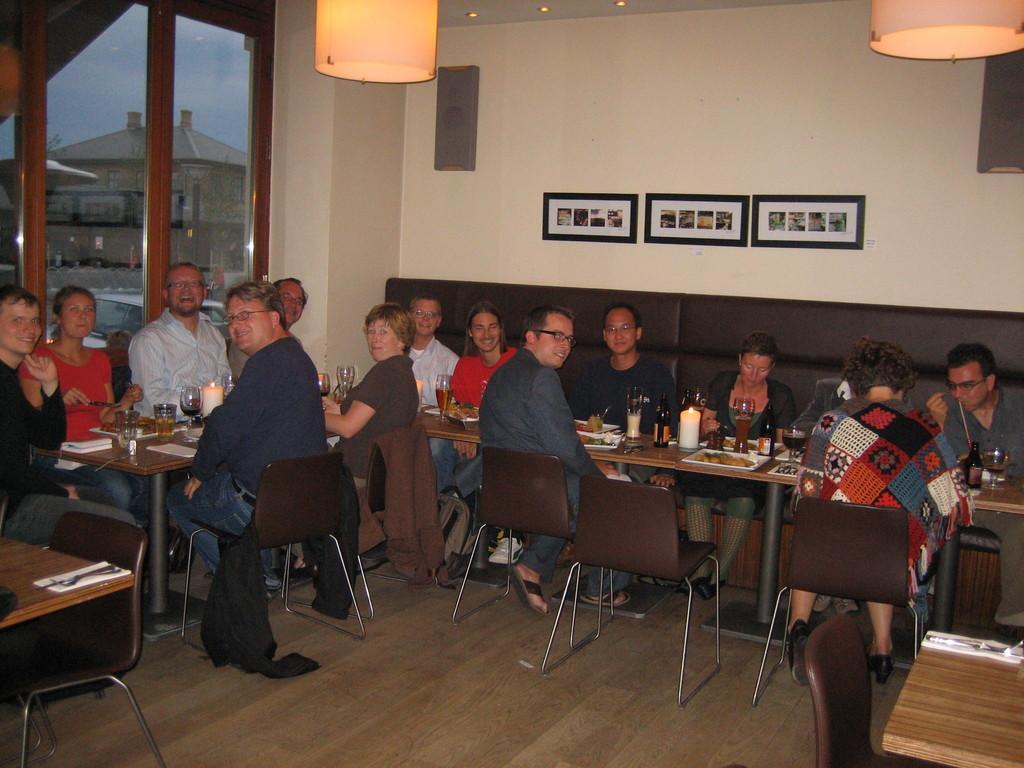Can you describe this image briefly? As we can see in the image there is a white color wall, photo frames, lights, windows, outside the windows there is a building and there are few people sitting on chairs and there is a table. On table there is a candle, plate, glasses and food items. 